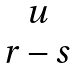<formula> <loc_0><loc_0><loc_500><loc_500>\begin{matrix} u \\ r - s \end{matrix}</formula> 